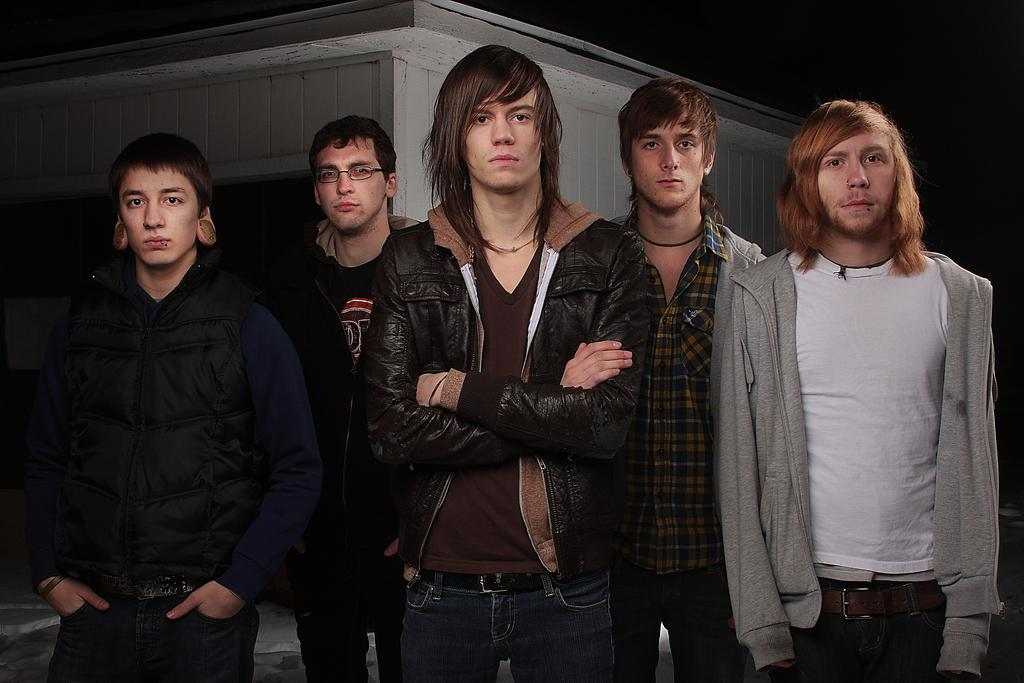What is happening in the front of the image? There is a group of people standing in the front of the image. What can be seen in the background of the image? There is a shed in the background of the image. What song is being sung by the group of people in the image? There is no indication of a song being sung in the image; it only shows a group of people standing. Can you see a match being lit in the image? There is no match or any indication of fire in the image. 